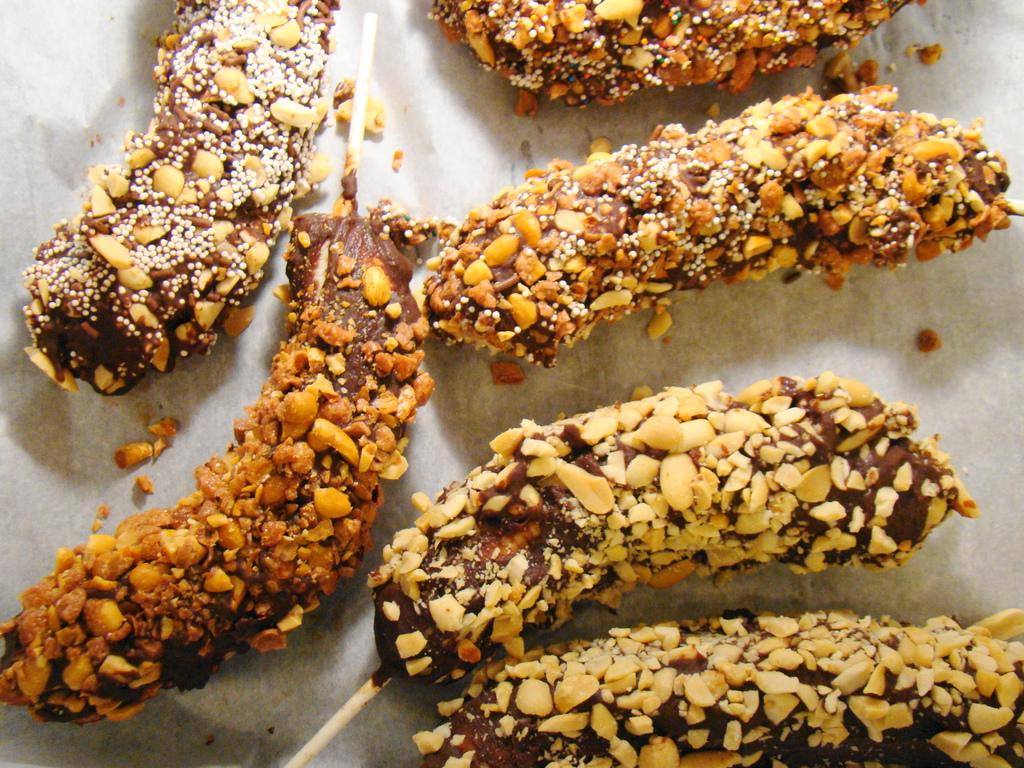What is the color of the surface in the image? The surface in the image is white. What can be found on the white surface? There are food items on the surface. Can you describe the colors of the food items? The food items have various colors, including brown, orange, white, and cream. What is associated with the food items? There are sticks associated with the food items. What type of music is playing in the background of the image? There is no music present in the image; it only features food items on a white surface with sticks. 